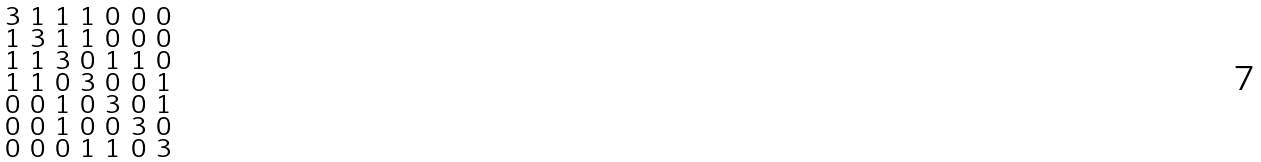<formula> <loc_0><loc_0><loc_500><loc_500>\begin{smallmatrix} 3 & 1 & 1 & 1 & 0 & 0 & 0 \\ 1 & 3 & 1 & 1 & 0 & 0 & 0 \\ 1 & 1 & 3 & 0 & 1 & 1 & 0 \\ 1 & 1 & 0 & 3 & 0 & 0 & 1 \\ 0 & 0 & 1 & 0 & 3 & 0 & 1 \\ 0 & 0 & 1 & 0 & 0 & 3 & 0 \\ 0 & 0 & 0 & 1 & 1 & 0 & 3 \end{smallmatrix}</formula> 